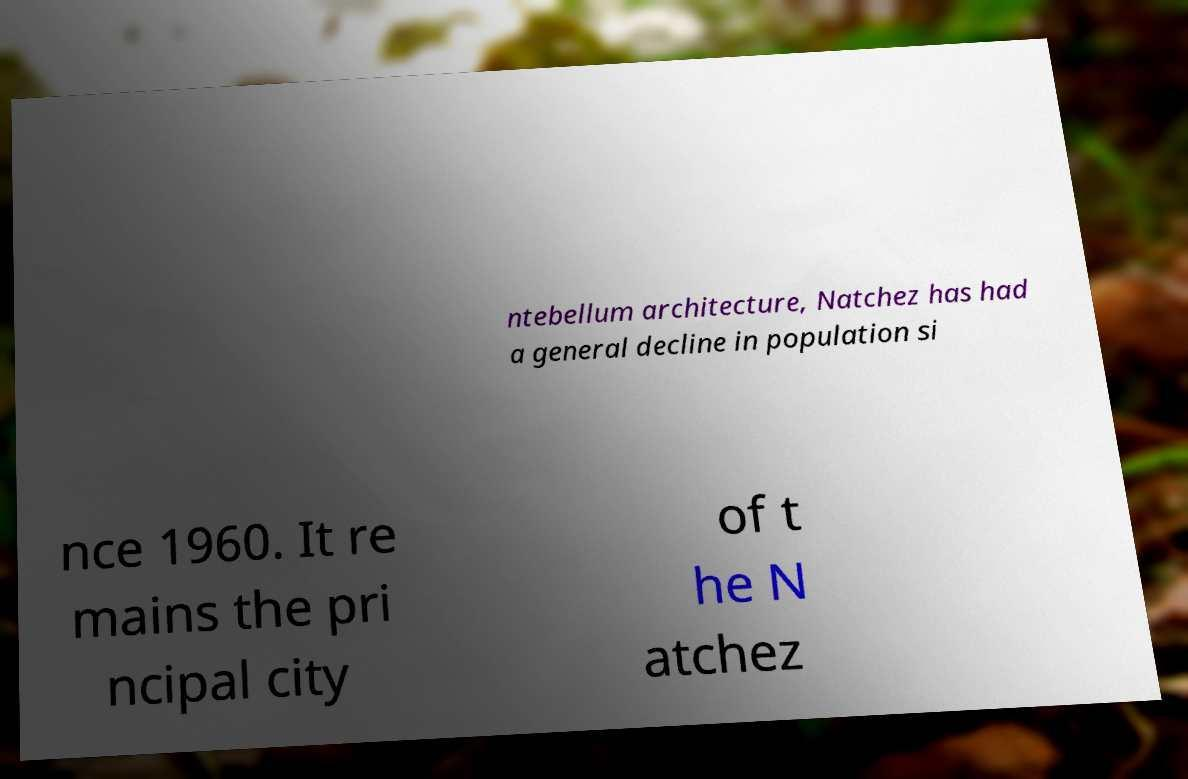What messages or text are displayed in this image? I need them in a readable, typed format. ntebellum architecture, Natchez has had a general decline in population si nce 1960. It re mains the pri ncipal city of t he N atchez 